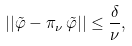<formula> <loc_0><loc_0><loc_500><loc_500>| | \tilde { \varphi } - \pi _ { \nu } \, \tilde { \varphi } | | \leq \frac { \delta } { \nu } ,</formula> 